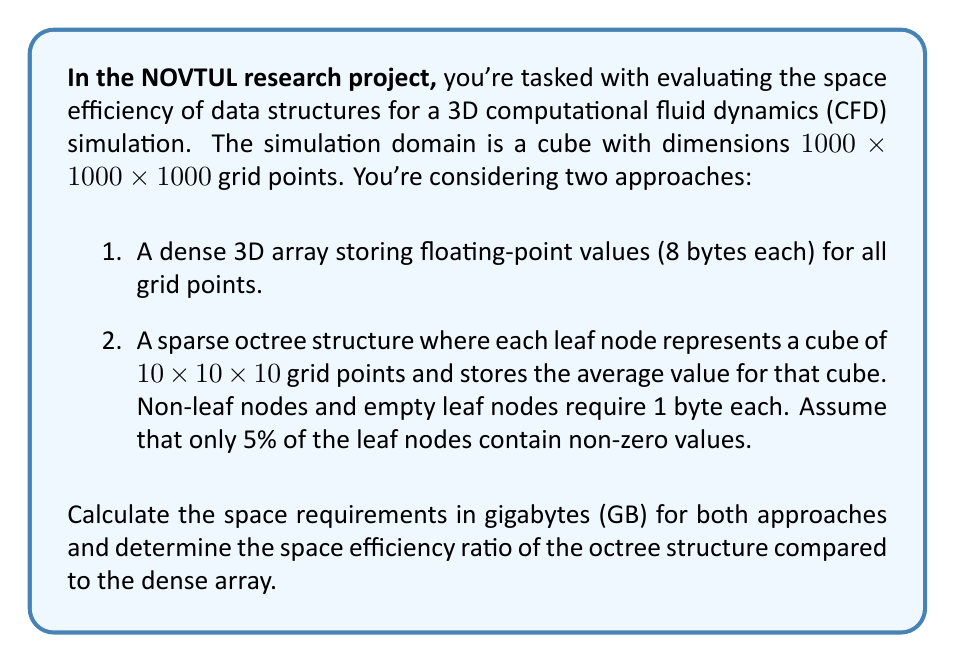Help me with this question. Let's approach this step-by-step:

1. Dense 3D array:
   - Total grid points: $1000 \times 1000 \times 1000 = 10^9$
   - Each point requires 8 bytes
   - Total space: $10^9 \times 8 = 8 \times 10^9$ bytes

2. Sparse octree:
   - Leaf nodes:
     * Total possible leaf nodes: $\frac{1000}{10} \times \frac{1000}{10} \times \frac{1000}{10} = 10^6$
     * Non-zero leaf nodes: $5\% \times 10^6 = 5 \times 10^4$
     * Space for non-zero leaf nodes: $5 \times 10^4 \times 8 = 4 \times 10^5$ bytes
   - Tree structure:
     * In a perfect octree, the number of internal nodes is $\frac{N-1}{7}$, where N is the total number of nodes
     * Total nodes: $10^6 + \frac{10^6-1}{7} \approx 1.14 \times 10^6$
     * Space for tree structure: $1.14 \times 10^6 \times 1 = 1.14 \times 10^6$ bytes
   - Total space: $(4 \times 10^5) + (1.14 \times 10^6) = 1.54 \times 10^6$ bytes

3. Convert to GB:
   - Dense array: $\frac{8 \times 10^9}{10^9} = 8$ GB
   - Sparse octree: $\frac{1.54 \times 10^6}{10^9} \approx 0.00154$ GB

4. Space efficiency ratio:
   $$\text{Ratio} = \frac{\text{Octree space}}{\text{Dense array space}} = \frac{0.00154}{8} \approx 0.0001925$$

This means the octree structure uses only about 0.01925% of the space used by the dense array.
Answer: Dense array: 8 GB
Sparse octree: 0.00154 GB
Space efficiency ratio: 0.0001925 (The octree uses approximately 0.01925% of the space used by the dense array) 